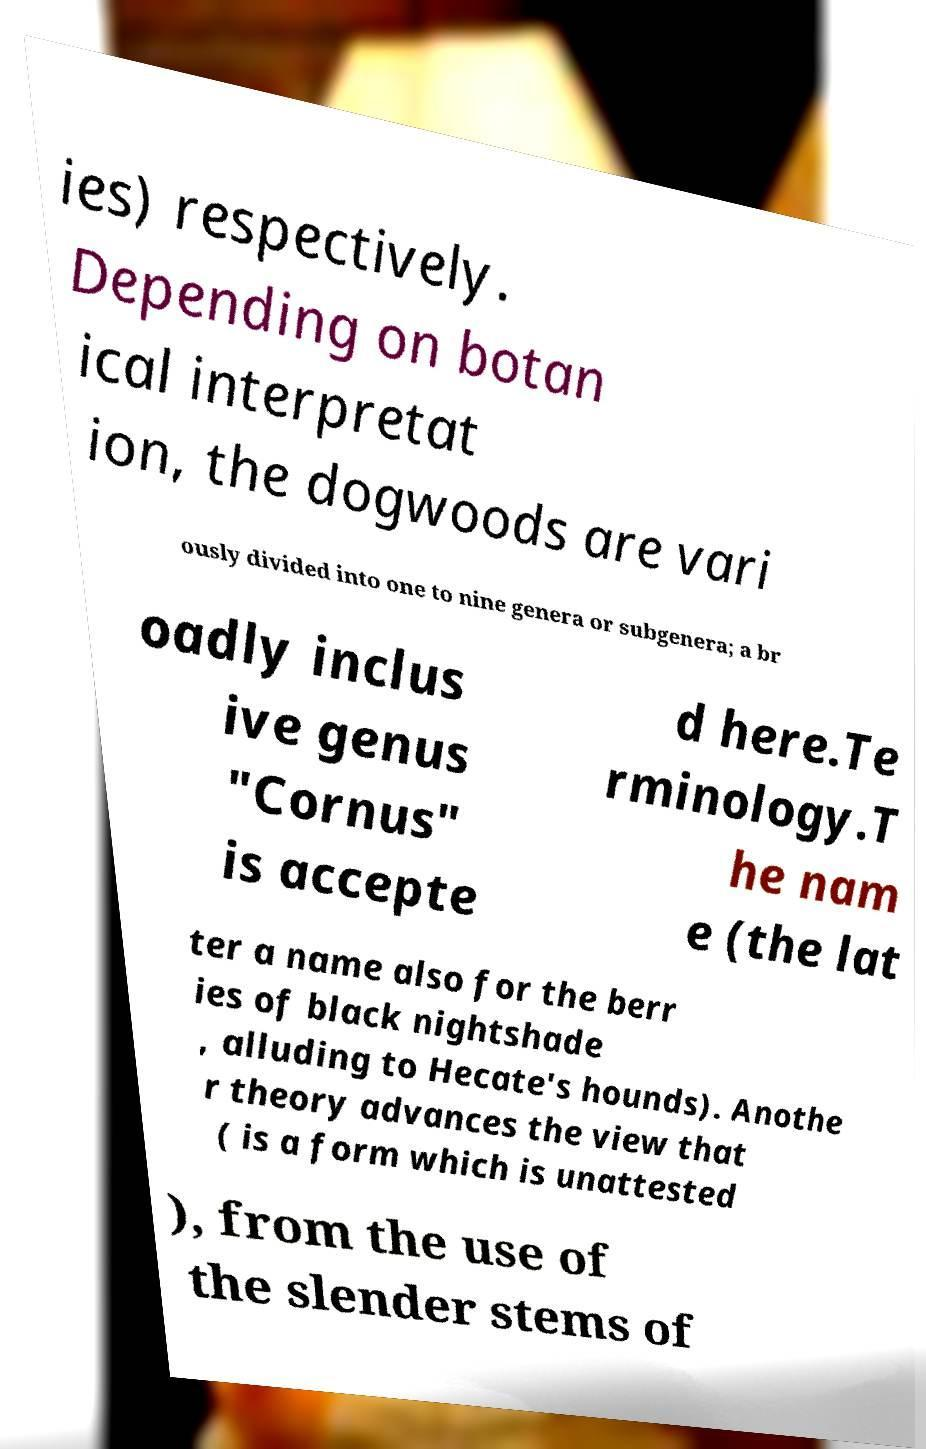For documentation purposes, I need the text within this image transcribed. Could you provide that? ies) respectively. Depending on botan ical interpretat ion, the dogwoods are vari ously divided into one to nine genera or subgenera; a br oadly inclus ive genus "Cornus" is accepte d here.Te rminology.T he nam e (the lat ter a name also for the berr ies of black nightshade , alluding to Hecate's hounds). Anothe r theory advances the view that ( is a form which is unattested ), from the use of the slender stems of 